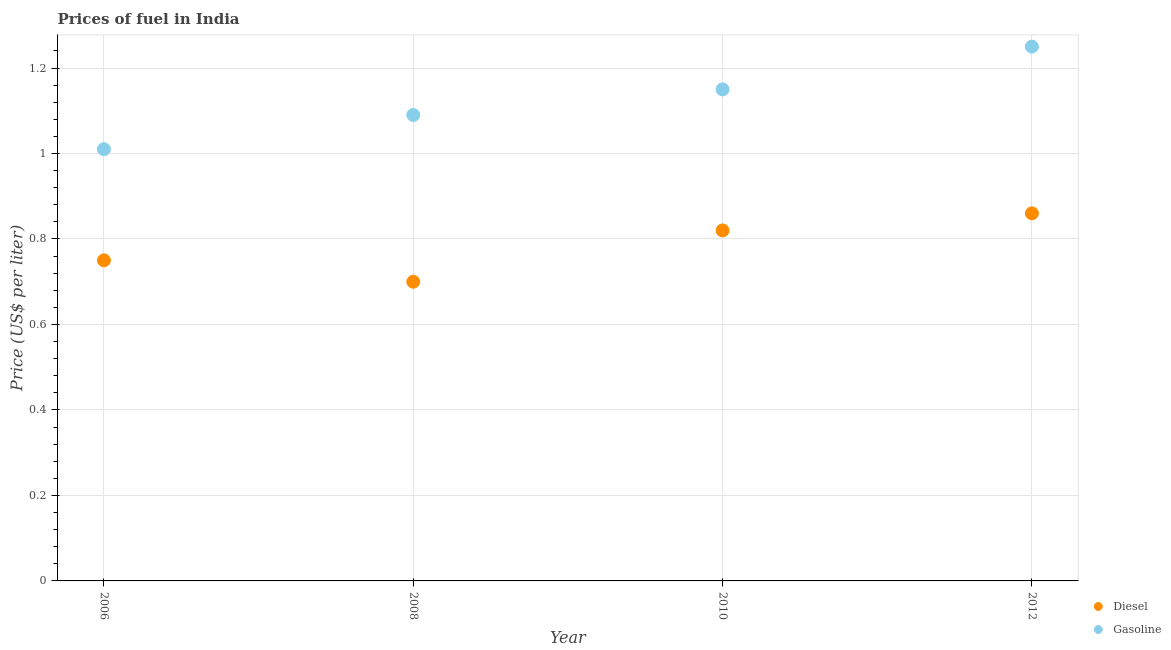What is the gasoline price in 2010?
Ensure brevity in your answer.  1.15. Across all years, what is the maximum gasoline price?
Your response must be concise. 1.25. In which year was the diesel price minimum?
Your response must be concise. 2008. What is the total diesel price in the graph?
Provide a short and direct response. 3.13. What is the difference between the gasoline price in 2006 and that in 2008?
Make the answer very short. -0.08. What is the average gasoline price per year?
Give a very brief answer. 1.12. In the year 2006, what is the difference between the diesel price and gasoline price?
Offer a very short reply. -0.26. In how many years, is the gasoline price greater than 0.8400000000000001 US$ per litre?
Your response must be concise. 4. What is the ratio of the gasoline price in 2006 to that in 2012?
Give a very brief answer. 0.81. Is the gasoline price in 2006 less than that in 2010?
Your answer should be compact. Yes. Is the difference between the diesel price in 2008 and 2012 greater than the difference between the gasoline price in 2008 and 2012?
Keep it short and to the point. No. What is the difference between the highest and the second highest gasoline price?
Your answer should be compact. 0.1. What is the difference between the highest and the lowest gasoline price?
Your answer should be compact. 0.24. Is the sum of the gasoline price in 2006 and 2012 greater than the maximum diesel price across all years?
Your answer should be compact. Yes. Does the diesel price monotonically increase over the years?
Offer a terse response. No. Is the diesel price strictly greater than the gasoline price over the years?
Offer a terse response. No. What is the difference between two consecutive major ticks on the Y-axis?
Your answer should be compact. 0.2. Are the values on the major ticks of Y-axis written in scientific E-notation?
Your answer should be compact. No. Does the graph contain any zero values?
Make the answer very short. No. Where does the legend appear in the graph?
Provide a short and direct response. Bottom right. How are the legend labels stacked?
Provide a short and direct response. Vertical. What is the title of the graph?
Your answer should be very brief. Prices of fuel in India. Does "Unregistered firms" appear as one of the legend labels in the graph?
Your answer should be compact. No. What is the label or title of the Y-axis?
Your response must be concise. Price (US$ per liter). What is the Price (US$ per liter) in Gasoline in 2008?
Your answer should be very brief. 1.09. What is the Price (US$ per liter) in Diesel in 2010?
Give a very brief answer. 0.82. What is the Price (US$ per liter) in Gasoline in 2010?
Provide a short and direct response. 1.15. What is the Price (US$ per liter) of Diesel in 2012?
Provide a short and direct response. 0.86. What is the Price (US$ per liter) in Gasoline in 2012?
Provide a short and direct response. 1.25. Across all years, what is the maximum Price (US$ per liter) of Diesel?
Provide a short and direct response. 0.86. Across all years, what is the minimum Price (US$ per liter) of Diesel?
Your answer should be very brief. 0.7. What is the total Price (US$ per liter) in Diesel in the graph?
Offer a very short reply. 3.13. What is the total Price (US$ per liter) in Gasoline in the graph?
Provide a short and direct response. 4.5. What is the difference between the Price (US$ per liter) of Diesel in 2006 and that in 2008?
Your answer should be compact. 0.05. What is the difference between the Price (US$ per liter) of Gasoline in 2006 and that in 2008?
Make the answer very short. -0.08. What is the difference between the Price (US$ per liter) in Diesel in 2006 and that in 2010?
Provide a short and direct response. -0.07. What is the difference between the Price (US$ per liter) in Gasoline in 2006 and that in 2010?
Ensure brevity in your answer.  -0.14. What is the difference between the Price (US$ per liter) in Diesel in 2006 and that in 2012?
Offer a very short reply. -0.11. What is the difference between the Price (US$ per liter) of Gasoline in 2006 and that in 2012?
Keep it short and to the point. -0.24. What is the difference between the Price (US$ per liter) of Diesel in 2008 and that in 2010?
Keep it short and to the point. -0.12. What is the difference between the Price (US$ per liter) of Gasoline in 2008 and that in 2010?
Give a very brief answer. -0.06. What is the difference between the Price (US$ per liter) in Diesel in 2008 and that in 2012?
Your answer should be compact. -0.16. What is the difference between the Price (US$ per liter) in Gasoline in 2008 and that in 2012?
Your answer should be very brief. -0.16. What is the difference between the Price (US$ per liter) of Diesel in 2010 and that in 2012?
Your answer should be very brief. -0.04. What is the difference between the Price (US$ per liter) in Diesel in 2006 and the Price (US$ per liter) in Gasoline in 2008?
Your answer should be compact. -0.34. What is the difference between the Price (US$ per liter) in Diesel in 2006 and the Price (US$ per liter) in Gasoline in 2012?
Your response must be concise. -0.5. What is the difference between the Price (US$ per liter) in Diesel in 2008 and the Price (US$ per liter) in Gasoline in 2010?
Provide a short and direct response. -0.45. What is the difference between the Price (US$ per liter) of Diesel in 2008 and the Price (US$ per liter) of Gasoline in 2012?
Your response must be concise. -0.55. What is the difference between the Price (US$ per liter) in Diesel in 2010 and the Price (US$ per liter) in Gasoline in 2012?
Make the answer very short. -0.43. What is the average Price (US$ per liter) of Diesel per year?
Offer a very short reply. 0.78. What is the average Price (US$ per liter) of Gasoline per year?
Make the answer very short. 1.12. In the year 2006, what is the difference between the Price (US$ per liter) in Diesel and Price (US$ per liter) in Gasoline?
Offer a very short reply. -0.26. In the year 2008, what is the difference between the Price (US$ per liter) of Diesel and Price (US$ per liter) of Gasoline?
Your answer should be compact. -0.39. In the year 2010, what is the difference between the Price (US$ per liter) in Diesel and Price (US$ per liter) in Gasoline?
Your response must be concise. -0.33. In the year 2012, what is the difference between the Price (US$ per liter) of Diesel and Price (US$ per liter) of Gasoline?
Provide a short and direct response. -0.39. What is the ratio of the Price (US$ per liter) in Diesel in 2006 to that in 2008?
Make the answer very short. 1.07. What is the ratio of the Price (US$ per liter) in Gasoline in 2006 to that in 2008?
Offer a very short reply. 0.93. What is the ratio of the Price (US$ per liter) of Diesel in 2006 to that in 2010?
Your answer should be very brief. 0.91. What is the ratio of the Price (US$ per liter) in Gasoline in 2006 to that in 2010?
Keep it short and to the point. 0.88. What is the ratio of the Price (US$ per liter) in Diesel in 2006 to that in 2012?
Your answer should be compact. 0.87. What is the ratio of the Price (US$ per liter) in Gasoline in 2006 to that in 2012?
Your answer should be very brief. 0.81. What is the ratio of the Price (US$ per liter) of Diesel in 2008 to that in 2010?
Your answer should be very brief. 0.85. What is the ratio of the Price (US$ per liter) in Gasoline in 2008 to that in 2010?
Your response must be concise. 0.95. What is the ratio of the Price (US$ per liter) in Diesel in 2008 to that in 2012?
Offer a very short reply. 0.81. What is the ratio of the Price (US$ per liter) of Gasoline in 2008 to that in 2012?
Provide a succinct answer. 0.87. What is the ratio of the Price (US$ per liter) of Diesel in 2010 to that in 2012?
Provide a short and direct response. 0.95. What is the ratio of the Price (US$ per liter) in Gasoline in 2010 to that in 2012?
Provide a succinct answer. 0.92. What is the difference between the highest and the second highest Price (US$ per liter) of Diesel?
Your response must be concise. 0.04. What is the difference between the highest and the lowest Price (US$ per liter) in Diesel?
Provide a short and direct response. 0.16. What is the difference between the highest and the lowest Price (US$ per liter) in Gasoline?
Provide a succinct answer. 0.24. 